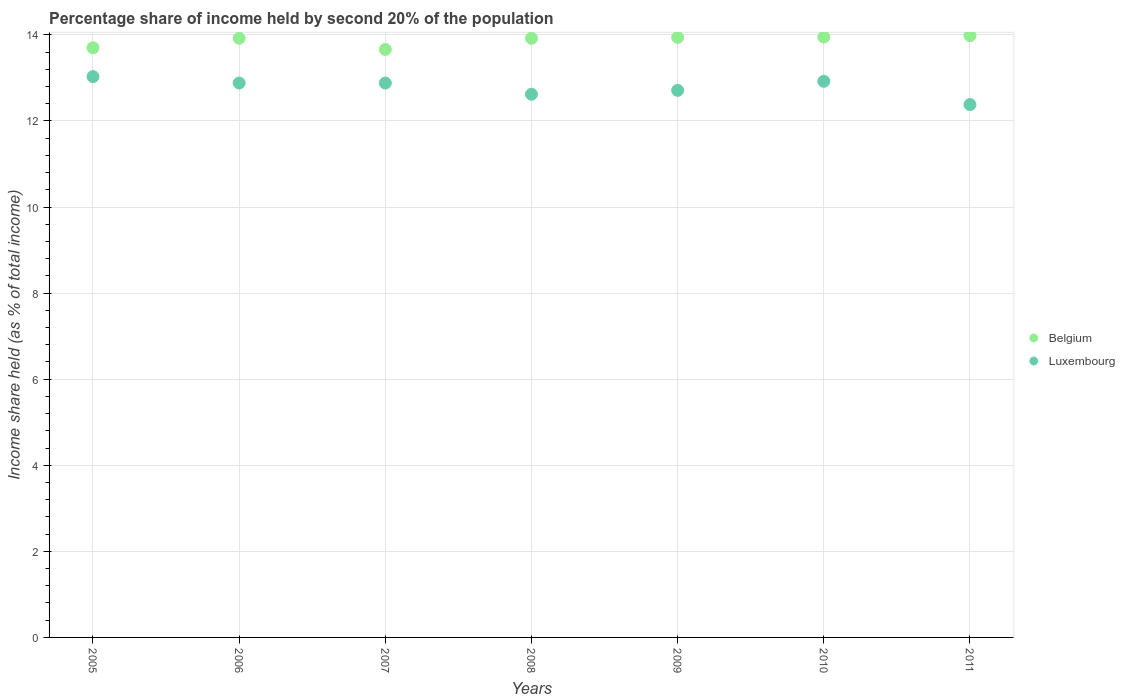What is the share of income held by second 20% of the population in Luxembourg in 2006?
Ensure brevity in your answer.  12.88. Across all years, what is the maximum share of income held by second 20% of the population in Belgium?
Provide a short and direct response. 13.98. Across all years, what is the minimum share of income held by second 20% of the population in Luxembourg?
Make the answer very short. 12.38. In which year was the share of income held by second 20% of the population in Luxembourg maximum?
Your response must be concise. 2005. In which year was the share of income held by second 20% of the population in Belgium minimum?
Your answer should be very brief. 2007. What is the total share of income held by second 20% of the population in Belgium in the graph?
Ensure brevity in your answer.  97.07. What is the difference between the share of income held by second 20% of the population in Belgium in 2009 and that in 2011?
Provide a short and direct response. -0.04. What is the difference between the share of income held by second 20% of the population in Luxembourg in 2006 and the share of income held by second 20% of the population in Belgium in 2010?
Provide a short and direct response. -1.07. What is the average share of income held by second 20% of the population in Belgium per year?
Offer a very short reply. 13.87. In the year 2008, what is the difference between the share of income held by second 20% of the population in Luxembourg and share of income held by second 20% of the population in Belgium?
Your answer should be compact. -1.3. What is the ratio of the share of income held by second 20% of the population in Belgium in 2007 to that in 2009?
Offer a very short reply. 0.98. What is the difference between the highest and the second highest share of income held by second 20% of the population in Luxembourg?
Provide a short and direct response. 0.11. What is the difference between the highest and the lowest share of income held by second 20% of the population in Belgium?
Keep it short and to the point. 0.32. What is the difference between two consecutive major ticks on the Y-axis?
Ensure brevity in your answer.  2. Are the values on the major ticks of Y-axis written in scientific E-notation?
Make the answer very short. No. Does the graph contain any zero values?
Provide a short and direct response. No. Does the graph contain grids?
Your answer should be compact. Yes. How are the legend labels stacked?
Keep it short and to the point. Vertical. What is the title of the graph?
Your answer should be compact. Percentage share of income held by second 20% of the population. What is the label or title of the Y-axis?
Offer a terse response. Income share held (as % of total income). What is the Income share held (as % of total income) in Belgium in 2005?
Offer a terse response. 13.7. What is the Income share held (as % of total income) in Luxembourg in 2005?
Make the answer very short. 13.03. What is the Income share held (as % of total income) of Belgium in 2006?
Provide a short and direct response. 13.92. What is the Income share held (as % of total income) of Luxembourg in 2006?
Make the answer very short. 12.88. What is the Income share held (as % of total income) in Belgium in 2007?
Give a very brief answer. 13.66. What is the Income share held (as % of total income) of Luxembourg in 2007?
Your answer should be very brief. 12.88. What is the Income share held (as % of total income) in Belgium in 2008?
Provide a succinct answer. 13.92. What is the Income share held (as % of total income) of Luxembourg in 2008?
Your answer should be compact. 12.62. What is the Income share held (as % of total income) in Belgium in 2009?
Ensure brevity in your answer.  13.94. What is the Income share held (as % of total income) of Luxembourg in 2009?
Your response must be concise. 12.71. What is the Income share held (as % of total income) of Belgium in 2010?
Your answer should be very brief. 13.95. What is the Income share held (as % of total income) in Luxembourg in 2010?
Keep it short and to the point. 12.92. What is the Income share held (as % of total income) in Belgium in 2011?
Provide a short and direct response. 13.98. What is the Income share held (as % of total income) of Luxembourg in 2011?
Your answer should be very brief. 12.38. Across all years, what is the maximum Income share held (as % of total income) in Belgium?
Your response must be concise. 13.98. Across all years, what is the maximum Income share held (as % of total income) in Luxembourg?
Ensure brevity in your answer.  13.03. Across all years, what is the minimum Income share held (as % of total income) of Belgium?
Offer a terse response. 13.66. Across all years, what is the minimum Income share held (as % of total income) of Luxembourg?
Provide a succinct answer. 12.38. What is the total Income share held (as % of total income) of Belgium in the graph?
Your answer should be very brief. 97.07. What is the total Income share held (as % of total income) of Luxembourg in the graph?
Your answer should be compact. 89.42. What is the difference between the Income share held (as % of total income) of Belgium in 2005 and that in 2006?
Ensure brevity in your answer.  -0.22. What is the difference between the Income share held (as % of total income) in Belgium in 2005 and that in 2007?
Keep it short and to the point. 0.04. What is the difference between the Income share held (as % of total income) of Belgium in 2005 and that in 2008?
Your answer should be very brief. -0.22. What is the difference between the Income share held (as % of total income) in Luxembourg in 2005 and that in 2008?
Your answer should be compact. 0.41. What is the difference between the Income share held (as % of total income) of Belgium in 2005 and that in 2009?
Make the answer very short. -0.24. What is the difference between the Income share held (as % of total income) of Luxembourg in 2005 and that in 2009?
Give a very brief answer. 0.32. What is the difference between the Income share held (as % of total income) of Luxembourg in 2005 and that in 2010?
Ensure brevity in your answer.  0.11. What is the difference between the Income share held (as % of total income) of Belgium in 2005 and that in 2011?
Keep it short and to the point. -0.28. What is the difference between the Income share held (as % of total income) in Luxembourg in 2005 and that in 2011?
Keep it short and to the point. 0.65. What is the difference between the Income share held (as % of total income) of Belgium in 2006 and that in 2007?
Make the answer very short. 0.26. What is the difference between the Income share held (as % of total income) in Luxembourg in 2006 and that in 2007?
Offer a terse response. 0. What is the difference between the Income share held (as % of total income) of Belgium in 2006 and that in 2008?
Keep it short and to the point. 0. What is the difference between the Income share held (as % of total income) in Luxembourg in 2006 and that in 2008?
Make the answer very short. 0.26. What is the difference between the Income share held (as % of total income) of Belgium in 2006 and that in 2009?
Provide a short and direct response. -0.02. What is the difference between the Income share held (as % of total income) in Luxembourg in 2006 and that in 2009?
Provide a short and direct response. 0.17. What is the difference between the Income share held (as % of total income) of Belgium in 2006 and that in 2010?
Offer a very short reply. -0.03. What is the difference between the Income share held (as % of total income) of Luxembourg in 2006 and that in 2010?
Provide a succinct answer. -0.04. What is the difference between the Income share held (as % of total income) of Belgium in 2006 and that in 2011?
Keep it short and to the point. -0.06. What is the difference between the Income share held (as % of total income) of Belgium in 2007 and that in 2008?
Provide a short and direct response. -0.26. What is the difference between the Income share held (as % of total income) of Luxembourg in 2007 and that in 2008?
Provide a short and direct response. 0.26. What is the difference between the Income share held (as % of total income) of Belgium in 2007 and that in 2009?
Your answer should be compact. -0.28. What is the difference between the Income share held (as % of total income) of Luxembourg in 2007 and that in 2009?
Ensure brevity in your answer.  0.17. What is the difference between the Income share held (as % of total income) in Belgium in 2007 and that in 2010?
Provide a short and direct response. -0.29. What is the difference between the Income share held (as % of total income) in Luxembourg in 2007 and that in 2010?
Your answer should be compact. -0.04. What is the difference between the Income share held (as % of total income) of Belgium in 2007 and that in 2011?
Your answer should be compact. -0.32. What is the difference between the Income share held (as % of total income) of Luxembourg in 2007 and that in 2011?
Your answer should be compact. 0.5. What is the difference between the Income share held (as % of total income) of Belgium in 2008 and that in 2009?
Offer a very short reply. -0.02. What is the difference between the Income share held (as % of total income) in Luxembourg in 2008 and that in 2009?
Make the answer very short. -0.09. What is the difference between the Income share held (as % of total income) in Belgium in 2008 and that in 2010?
Provide a succinct answer. -0.03. What is the difference between the Income share held (as % of total income) of Luxembourg in 2008 and that in 2010?
Your response must be concise. -0.3. What is the difference between the Income share held (as % of total income) in Belgium in 2008 and that in 2011?
Ensure brevity in your answer.  -0.06. What is the difference between the Income share held (as % of total income) in Luxembourg in 2008 and that in 2011?
Make the answer very short. 0.24. What is the difference between the Income share held (as % of total income) of Belgium in 2009 and that in 2010?
Your answer should be very brief. -0.01. What is the difference between the Income share held (as % of total income) in Luxembourg in 2009 and that in 2010?
Your response must be concise. -0.21. What is the difference between the Income share held (as % of total income) in Belgium in 2009 and that in 2011?
Your response must be concise. -0.04. What is the difference between the Income share held (as % of total income) in Luxembourg in 2009 and that in 2011?
Your response must be concise. 0.33. What is the difference between the Income share held (as % of total income) of Belgium in 2010 and that in 2011?
Provide a succinct answer. -0.03. What is the difference between the Income share held (as % of total income) of Luxembourg in 2010 and that in 2011?
Ensure brevity in your answer.  0.54. What is the difference between the Income share held (as % of total income) of Belgium in 2005 and the Income share held (as % of total income) of Luxembourg in 2006?
Give a very brief answer. 0.82. What is the difference between the Income share held (as % of total income) of Belgium in 2005 and the Income share held (as % of total income) of Luxembourg in 2007?
Provide a short and direct response. 0.82. What is the difference between the Income share held (as % of total income) in Belgium in 2005 and the Income share held (as % of total income) in Luxembourg in 2008?
Your response must be concise. 1.08. What is the difference between the Income share held (as % of total income) of Belgium in 2005 and the Income share held (as % of total income) of Luxembourg in 2010?
Keep it short and to the point. 0.78. What is the difference between the Income share held (as % of total income) in Belgium in 2005 and the Income share held (as % of total income) in Luxembourg in 2011?
Provide a short and direct response. 1.32. What is the difference between the Income share held (as % of total income) in Belgium in 2006 and the Income share held (as % of total income) in Luxembourg in 2008?
Your answer should be compact. 1.3. What is the difference between the Income share held (as % of total income) of Belgium in 2006 and the Income share held (as % of total income) of Luxembourg in 2009?
Keep it short and to the point. 1.21. What is the difference between the Income share held (as % of total income) of Belgium in 2006 and the Income share held (as % of total income) of Luxembourg in 2010?
Ensure brevity in your answer.  1. What is the difference between the Income share held (as % of total income) in Belgium in 2006 and the Income share held (as % of total income) in Luxembourg in 2011?
Your response must be concise. 1.54. What is the difference between the Income share held (as % of total income) of Belgium in 2007 and the Income share held (as % of total income) of Luxembourg in 2008?
Offer a very short reply. 1.04. What is the difference between the Income share held (as % of total income) of Belgium in 2007 and the Income share held (as % of total income) of Luxembourg in 2010?
Offer a very short reply. 0.74. What is the difference between the Income share held (as % of total income) in Belgium in 2007 and the Income share held (as % of total income) in Luxembourg in 2011?
Provide a succinct answer. 1.28. What is the difference between the Income share held (as % of total income) in Belgium in 2008 and the Income share held (as % of total income) in Luxembourg in 2009?
Your response must be concise. 1.21. What is the difference between the Income share held (as % of total income) in Belgium in 2008 and the Income share held (as % of total income) in Luxembourg in 2010?
Your answer should be compact. 1. What is the difference between the Income share held (as % of total income) of Belgium in 2008 and the Income share held (as % of total income) of Luxembourg in 2011?
Give a very brief answer. 1.54. What is the difference between the Income share held (as % of total income) of Belgium in 2009 and the Income share held (as % of total income) of Luxembourg in 2010?
Your answer should be very brief. 1.02. What is the difference between the Income share held (as % of total income) of Belgium in 2009 and the Income share held (as % of total income) of Luxembourg in 2011?
Your response must be concise. 1.56. What is the difference between the Income share held (as % of total income) in Belgium in 2010 and the Income share held (as % of total income) in Luxembourg in 2011?
Your answer should be compact. 1.57. What is the average Income share held (as % of total income) of Belgium per year?
Your answer should be compact. 13.87. What is the average Income share held (as % of total income) in Luxembourg per year?
Provide a succinct answer. 12.77. In the year 2005, what is the difference between the Income share held (as % of total income) of Belgium and Income share held (as % of total income) of Luxembourg?
Ensure brevity in your answer.  0.67. In the year 2007, what is the difference between the Income share held (as % of total income) in Belgium and Income share held (as % of total income) in Luxembourg?
Make the answer very short. 0.78. In the year 2008, what is the difference between the Income share held (as % of total income) in Belgium and Income share held (as % of total income) in Luxembourg?
Your answer should be very brief. 1.3. In the year 2009, what is the difference between the Income share held (as % of total income) of Belgium and Income share held (as % of total income) of Luxembourg?
Your response must be concise. 1.23. In the year 2010, what is the difference between the Income share held (as % of total income) of Belgium and Income share held (as % of total income) of Luxembourg?
Keep it short and to the point. 1.03. In the year 2011, what is the difference between the Income share held (as % of total income) of Belgium and Income share held (as % of total income) of Luxembourg?
Give a very brief answer. 1.6. What is the ratio of the Income share held (as % of total income) of Belgium in 2005 to that in 2006?
Your response must be concise. 0.98. What is the ratio of the Income share held (as % of total income) of Luxembourg in 2005 to that in 2006?
Offer a very short reply. 1.01. What is the ratio of the Income share held (as % of total income) of Belgium in 2005 to that in 2007?
Your answer should be very brief. 1. What is the ratio of the Income share held (as % of total income) of Luxembourg in 2005 to that in 2007?
Offer a very short reply. 1.01. What is the ratio of the Income share held (as % of total income) in Belgium in 2005 to that in 2008?
Your answer should be very brief. 0.98. What is the ratio of the Income share held (as % of total income) in Luxembourg in 2005 to that in 2008?
Your answer should be compact. 1.03. What is the ratio of the Income share held (as % of total income) of Belgium in 2005 to that in 2009?
Your answer should be compact. 0.98. What is the ratio of the Income share held (as % of total income) of Luxembourg in 2005 to that in 2009?
Make the answer very short. 1.03. What is the ratio of the Income share held (as % of total income) in Belgium in 2005 to that in 2010?
Provide a short and direct response. 0.98. What is the ratio of the Income share held (as % of total income) in Luxembourg in 2005 to that in 2010?
Provide a short and direct response. 1.01. What is the ratio of the Income share held (as % of total income) in Luxembourg in 2005 to that in 2011?
Your response must be concise. 1.05. What is the ratio of the Income share held (as % of total income) of Belgium in 2006 to that in 2007?
Your answer should be compact. 1.02. What is the ratio of the Income share held (as % of total income) in Luxembourg in 2006 to that in 2008?
Your answer should be compact. 1.02. What is the ratio of the Income share held (as % of total income) of Belgium in 2006 to that in 2009?
Offer a terse response. 1. What is the ratio of the Income share held (as % of total income) of Luxembourg in 2006 to that in 2009?
Your answer should be very brief. 1.01. What is the ratio of the Income share held (as % of total income) of Belgium in 2006 to that in 2010?
Make the answer very short. 1. What is the ratio of the Income share held (as % of total income) in Belgium in 2006 to that in 2011?
Give a very brief answer. 1. What is the ratio of the Income share held (as % of total income) in Luxembourg in 2006 to that in 2011?
Your response must be concise. 1.04. What is the ratio of the Income share held (as % of total income) of Belgium in 2007 to that in 2008?
Provide a succinct answer. 0.98. What is the ratio of the Income share held (as % of total income) in Luxembourg in 2007 to that in 2008?
Offer a terse response. 1.02. What is the ratio of the Income share held (as % of total income) in Belgium in 2007 to that in 2009?
Your response must be concise. 0.98. What is the ratio of the Income share held (as % of total income) in Luxembourg in 2007 to that in 2009?
Keep it short and to the point. 1.01. What is the ratio of the Income share held (as % of total income) of Belgium in 2007 to that in 2010?
Provide a succinct answer. 0.98. What is the ratio of the Income share held (as % of total income) of Luxembourg in 2007 to that in 2010?
Your answer should be very brief. 1. What is the ratio of the Income share held (as % of total income) in Belgium in 2007 to that in 2011?
Provide a short and direct response. 0.98. What is the ratio of the Income share held (as % of total income) of Luxembourg in 2007 to that in 2011?
Your response must be concise. 1.04. What is the ratio of the Income share held (as % of total income) in Luxembourg in 2008 to that in 2010?
Ensure brevity in your answer.  0.98. What is the ratio of the Income share held (as % of total income) of Belgium in 2008 to that in 2011?
Your answer should be very brief. 1. What is the ratio of the Income share held (as % of total income) of Luxembourg in 2008 to that in 2011?
Make the answer very short. 1.02. What is the ratio of the Income share held (as % of total income) in Belgium in 2009 to that in 2010?
Your response must be concise. 1. What is the ratio of the Income share held (as % of total income) of Luxembourg in 2009 to that in 2010?
Give a very brief answer. 0.98. What is the ratio of the Income share held (as % of total income) of Luxembourg in 2009 to that in 2011?
Offer a very short reply. 1.03. What is the ratio of the Income share held (as % of total income) in Belgium in 2010 to that in 2011?
Your answer should be very brief. 1. What is the ratio of the Income share held (as % of total income) of Luxembourg in 2010 to that in 2011?
Ensure brevity in your answer.  1.04. What is the difference between the highest and the second highest Income share held (as % of total income) in Belgium?
Offer a very short reply. 0.03. What is the difference between the highest and the second highest Income share held (as % of total income) of Luxembourg?
Your response must be concise. 0.11. What is the difference between the highest and the lowest Income share held (as % of total income) of Belgium?
Provide a short and direct response. 0.32. What is the difference between the highest and the lowest Income share held (as % of total income) of Luxembourg?
Provide a short and direct response. 0.65. 